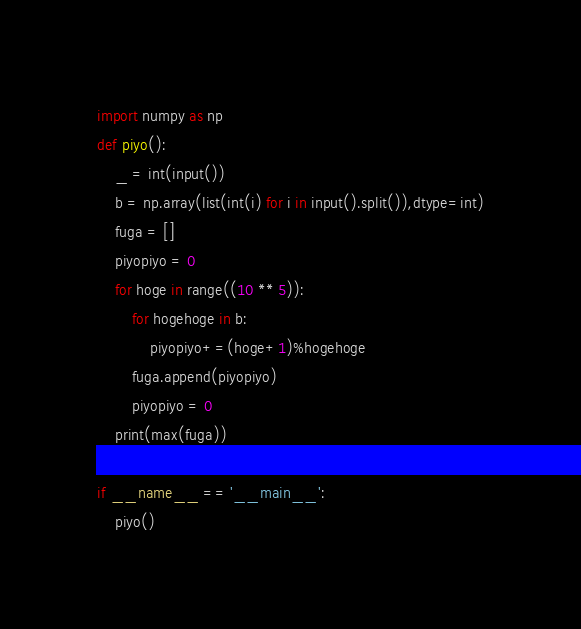<code> <loc_0><loc_0><loc_500><loc_500><_Python_>import numpy as np
def piyo():
    _ = int(input())
    b = np.array(list(int(i) for i in input().split()),dtype=int)
    fuga = []
    piyopiyo = 0
    for hoge in range((10 ** 5)):
        for hogehoge in b:
            piyopiyo+=(hoge+1)%hogehoge
        fuga.append(piyopiyo)
        piyopiyo = 0
    print(max(fuga))
        
if __name__ == '__main__':
    piyo()</code> 